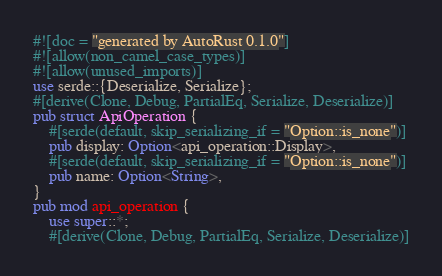Convert code to text. <code><loc_0><loc_0><loc_500><loc_500><_Rust_>#![doc = "generated by AutoRust 0.1.0"]
#![allow(non_camel_case_types)]
#![allow(unused_imports)]
use serde::{Deserialize, Serialize};
#[derive(Clone, Debug, PartialEq, Serialize, Deserialize)]
pub struct ApiOperation {
    #[serde(default, skip_serializing_if = "Option::is_none")]
    pub display: Option<api_operation::Display>,
    #[serde(default, skip_serializing_if = "Option::is_none")]
    pub name: Option<String>,
}
pub mod api_operation {
    use super::*;
    #[derive(Clone, Debug, PartialEq, Serialize, Deserialize)]</code> 